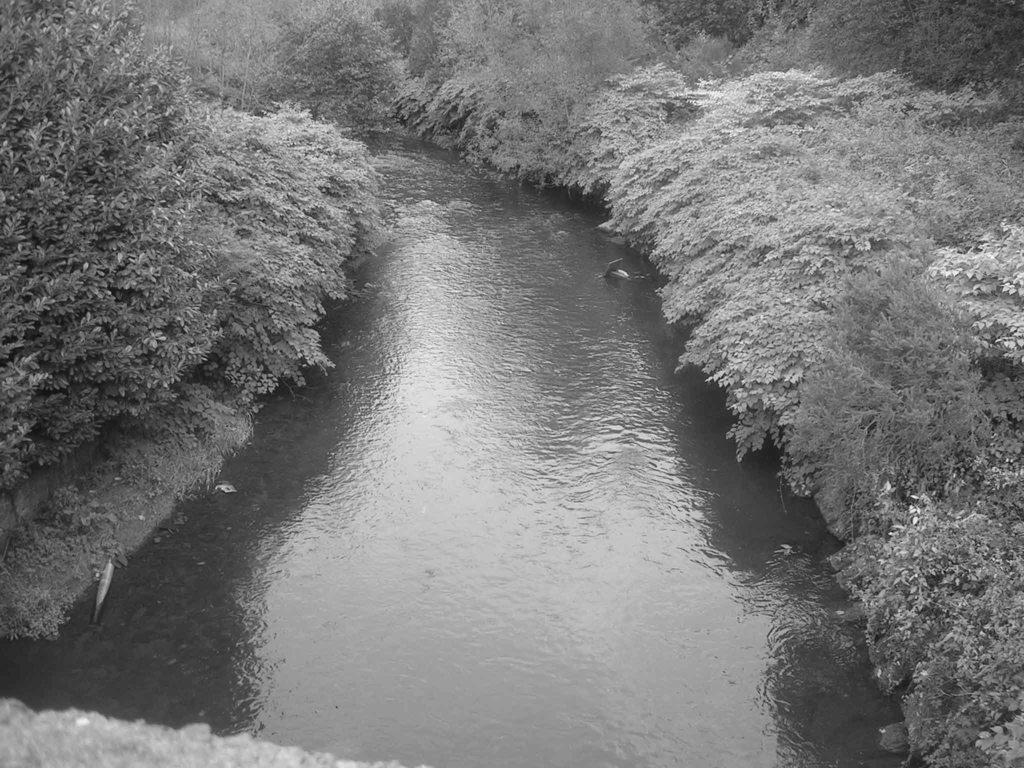What is the color scheme of the image? The image is black and white. What natural feature can be seen in the image? There is a river in the image. What type of vegetation is present in the image? There are trees in the image. What type of ground cover can be seen in the image? There is grass in the image. What type of crime is being committed in the image? There is no crime or criminal activity depicted in the image. Can you tell me the trade value of the trees in the image? There is no information about the trade value of the trees in the image. 